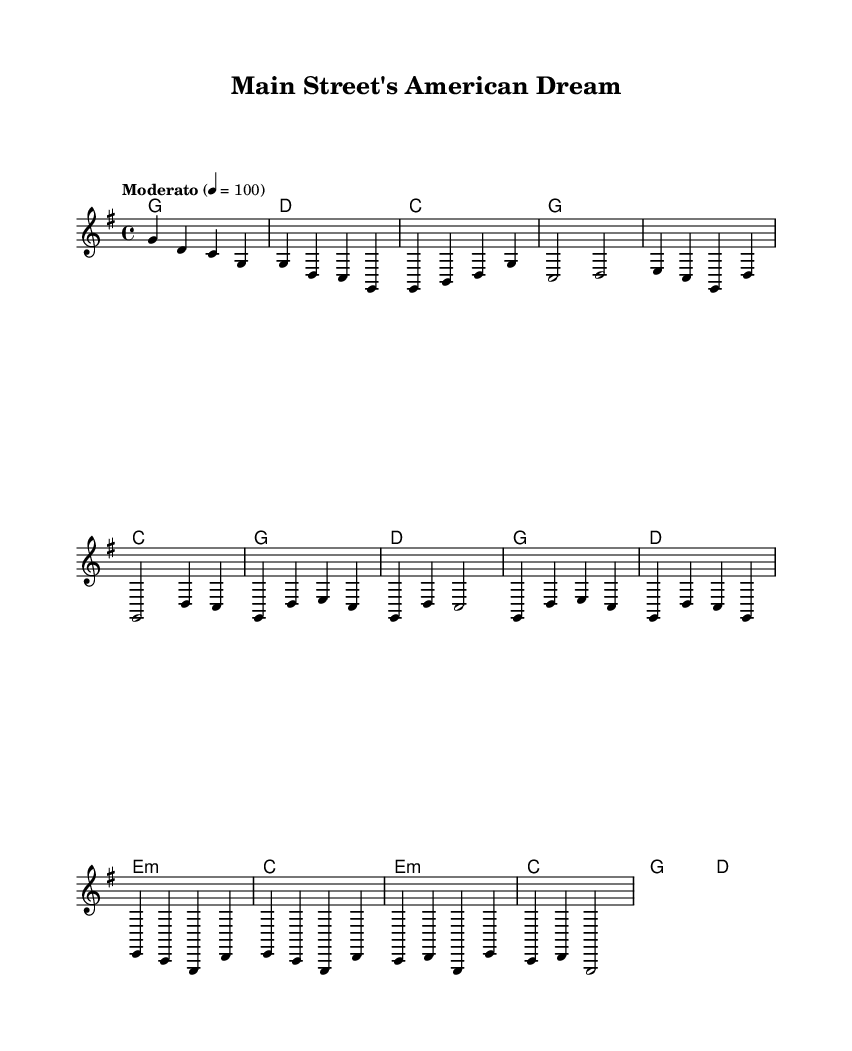What is the key signature of this music? The key signature is G major, which has one sharp (F#). This can be identified by looking at the beginning of the staff, where the one sharp indicates the key of G major.
Answer: G major What is the time signature of this music? The time signature is 4/4, as indicated at the beginning of the score. This means there are four beats in each measure, and the quarter note gets one beat.
Answer: 4/4 What is the tempo marking for this piece? The tempo marking is "Moderato," indicating a moderate speed, and it is further specified to be around 100 beats per minute. This is indicated in the score where the tempo is listed.
Answer: Moderato How many measures are in the chorus? The chorus consists of four measures, which can be confirmed by counting the measures from the beginning of the chorus section listed in the melody.
Answer: 4 What is the first chord in the bridge section? The first chord in the bridge section is E minor, which can be identified by looking at the chord progression given in the harmonies during the bridge part.
Answer: E minor Are there any repeated sections in the melody? Yes, there are repeated sections present, particularly in the chorus where the melody structure repeats after the first lapsed measures. This can be seen visually by noticing the similarity in the first and fourth measures of the chorus.
Answer: Yes 